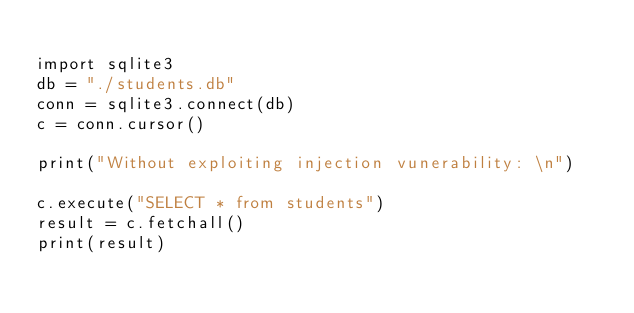<code> <loc_0><loc_0><loc_500><loc_500><_Bash_>
import sqlite3
db = "./students.db"
conn = sqlite3.connect(db)
c = conn.cursor()

print("Without exploiting injection vunerability: \n")
 
c.execute("SELECT * from students")
result = c.fetchall()
print(result)
</code> 